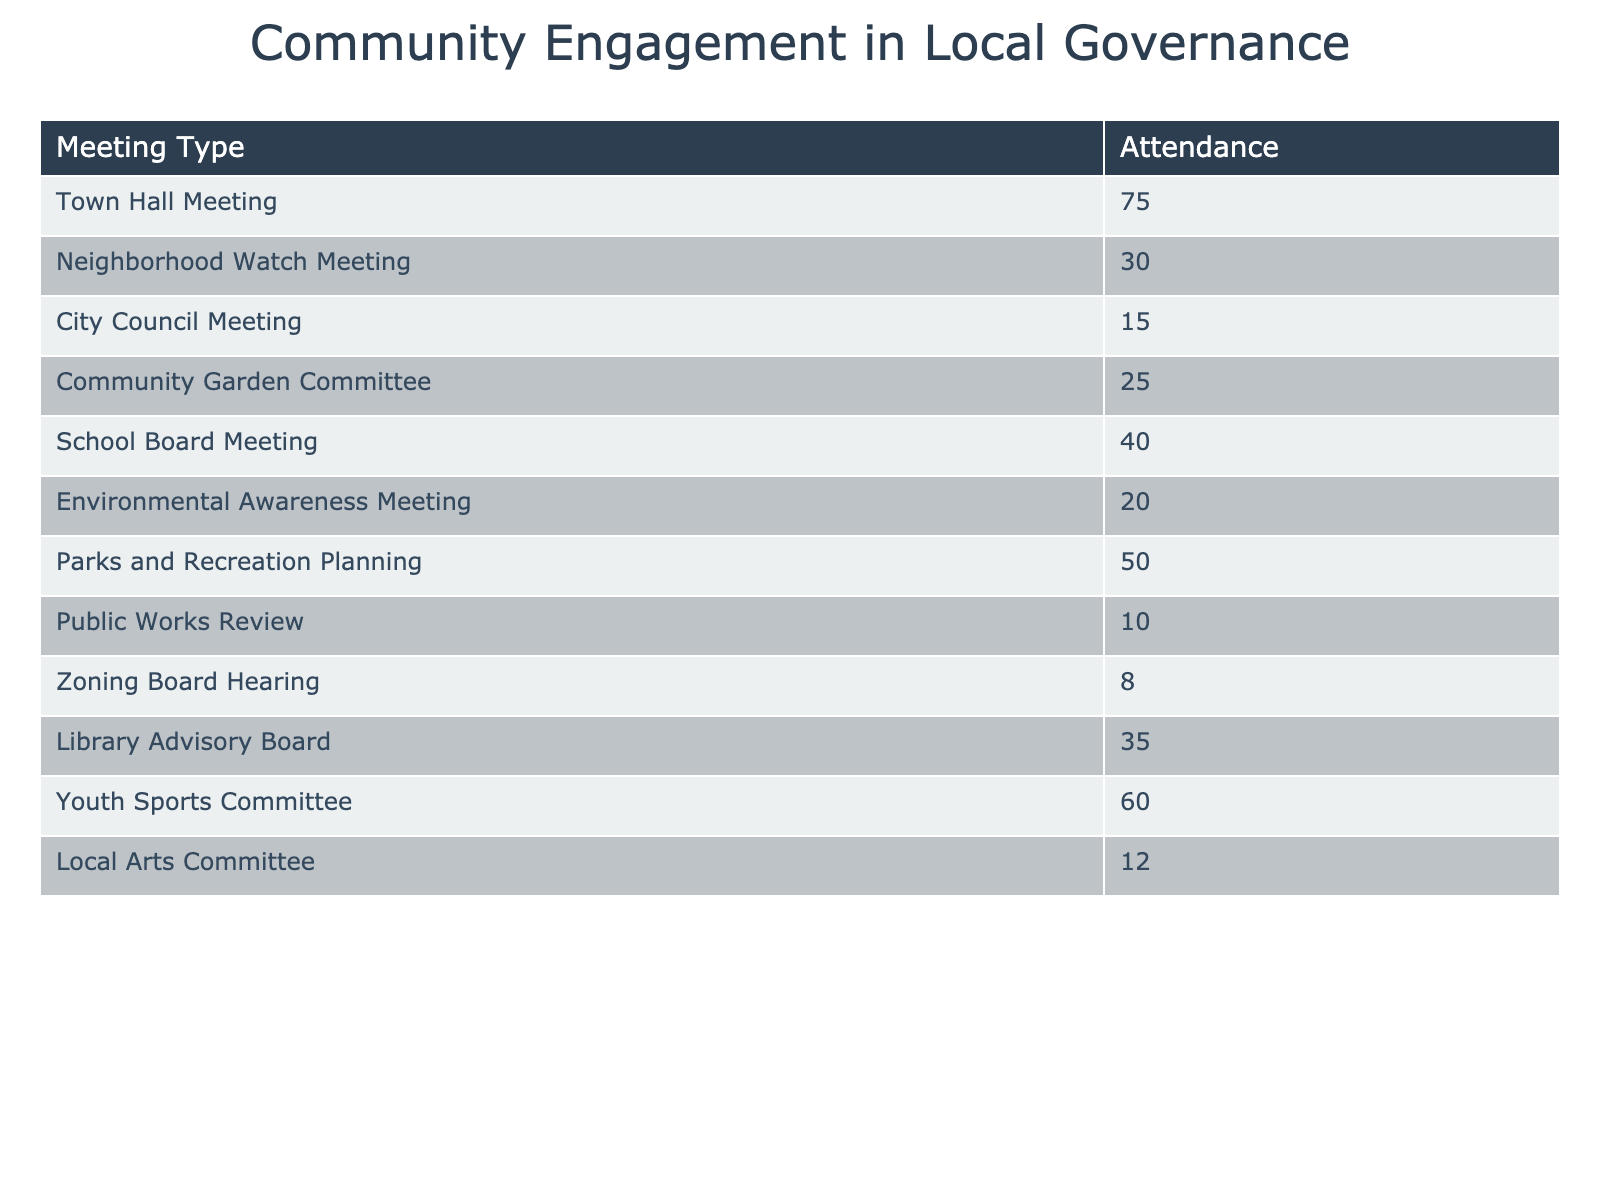What is the attendance at the Town Hall Meeting? The Town Hall Meeting has an attendance of 75, as listed in the table.
Answer: 75 Which meeting type has the lowest attendance? The Zoning Board Hearing has the lowest attendance of 8 according to the table.
Answer: 8 What is the total attendance for all meetings? Adding all the attendance values together gives (75 + 30 + 15 + 25 + 40 + 20 + 50 + 10 + 8 + 35 + 60 + 12) =  375.
Answer: 375 Is the attendance for the Library Advisory Board greater than 30? Yes, the attendance for the Library Advisory Board is 35, which is greater than 30.
Answer: Yes What is the average attendance across all meetings? To find the average, sum all attendances (375) and divide by the number of meetings (12), giving us an average of 31.25.
Answer: 31.25 How many meetings had an attendance of 50 or more? The meetings with an attendance of 50 or more are the Town Hall Meeting (75), Youth Sports Committee (60), and Parks and Recreation Planning (50), totaling 3 meetings.
Answer: 3 What is the difference between the attendance at the Youth Sports Committee and the City Council Meeting? The Youth Sports Committee had an attendance of 60, while the City Council Meeting had 15, so the difference is 60 - 15 = 45.
Answer: 45 Which meeting type had an attendance between 20 and 40? The Environmental Awareness Meeting (20), Community Garden Committee (25), and School Board Meeting (40) all have attendances in that range.
Answer: Environmental Awareness Meeting, Community Garden Committee, School Board Meeting Are there more meetings with an attendance under 30 than above 30? Yes, there are five meetings with attendance under 30 (Neighborhood Watch Meeting (30), Public Works Review (10), Zoning Board Hearing (8), Local Arts Committee (12)), while there are seven meetings above 30.
Answer: Yes 